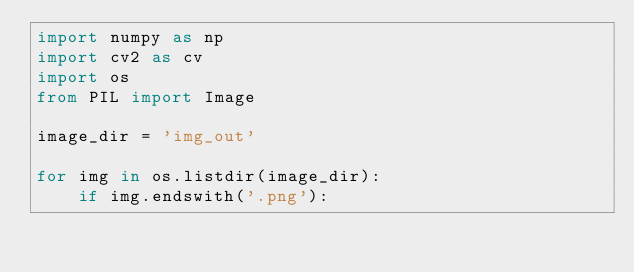<code> <loc_0><loc_0><loc_500><loc_500><_Python_>import numpy as np
import cv2 as cv
import os
from PIL import Image

image_dir = 'img_out'

for img in os.listdir(image_dir):
    if img.endswith('.png'):
        </code> 